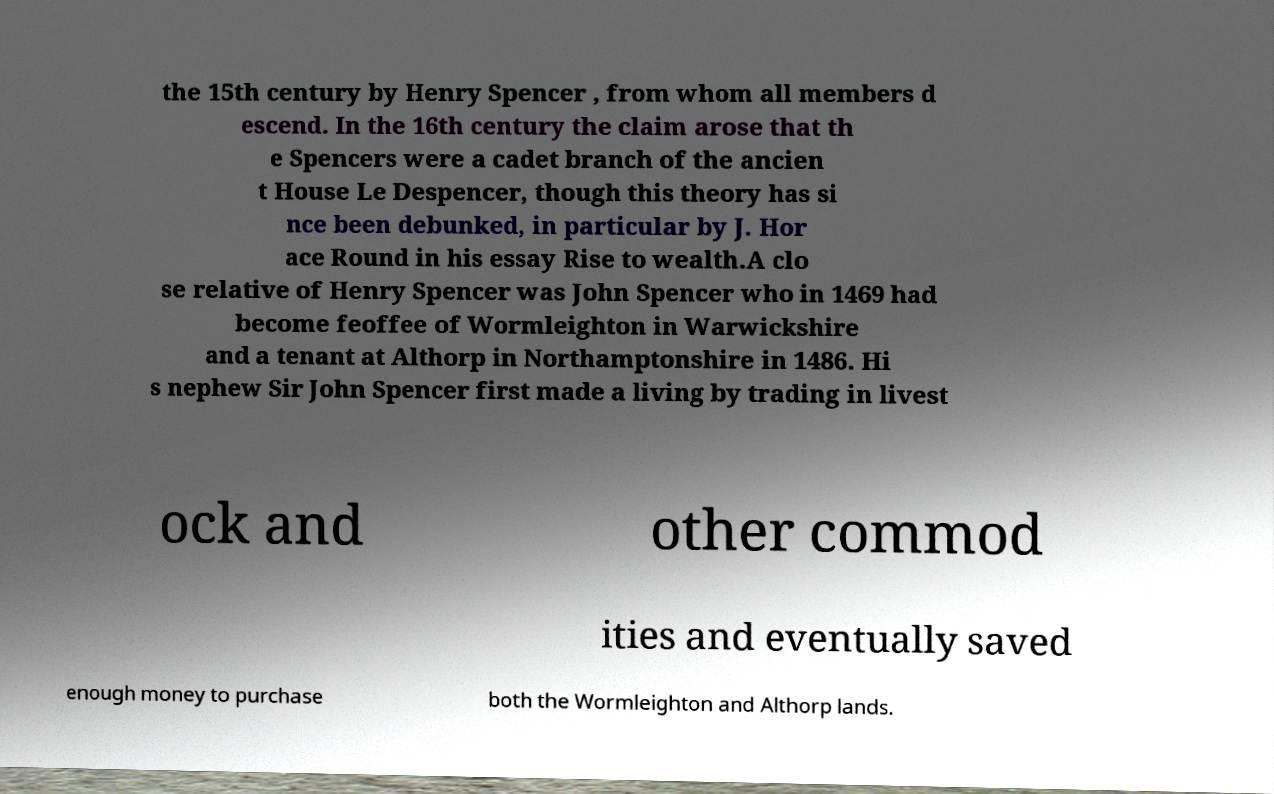Can you read and provide the text displayed in the image?This photo seems to have some interesting text. Can you extract and type it out for me? the 15th century by Henry Spencer , from whom all members d escend. In the 16th century the claim arose that th e Spencers were a cadet branch of the ancien t House Le Despencer, though this theory has si nce been debunked, in particular by J. Hor ace Round in his essay Rise to wealth.A clo se relative of Henry Spencer was John Spencer who in 1469 had become feoffee of Wormleighton in Warwickshire and a tenant at Althorp in Northamptonshire in 1486. Hi s nephew Sir John Spencer first made a living by trading in livest ock and other commod ities and eventually saved enough money to purchase both the Wormleighton and Althorp lands. 